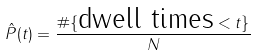<formula> <loc_0><loc_0><loc_500><loc_500>\hat { P } ( t ) = \frac { \# \{ \text {dwell times} < t \} } { N }</formula> 